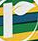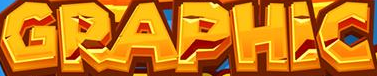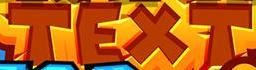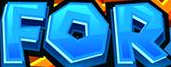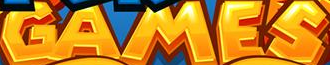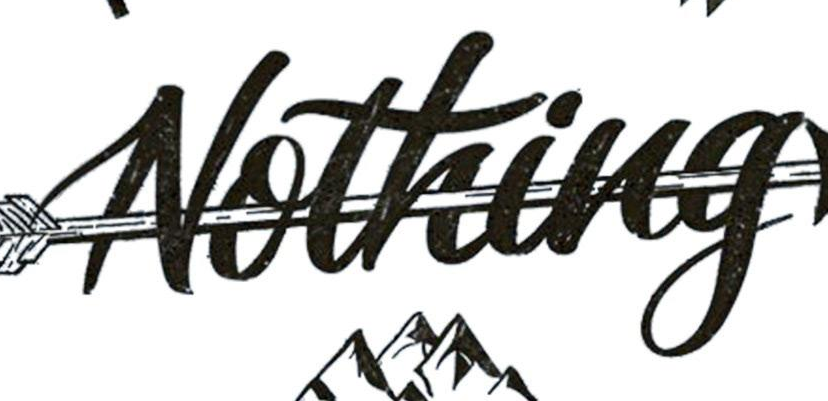What words can you see in these images in sequence, separated by a semicolon? r; GRAPHIC; TEXT; FOR; GAMES; Nothing 